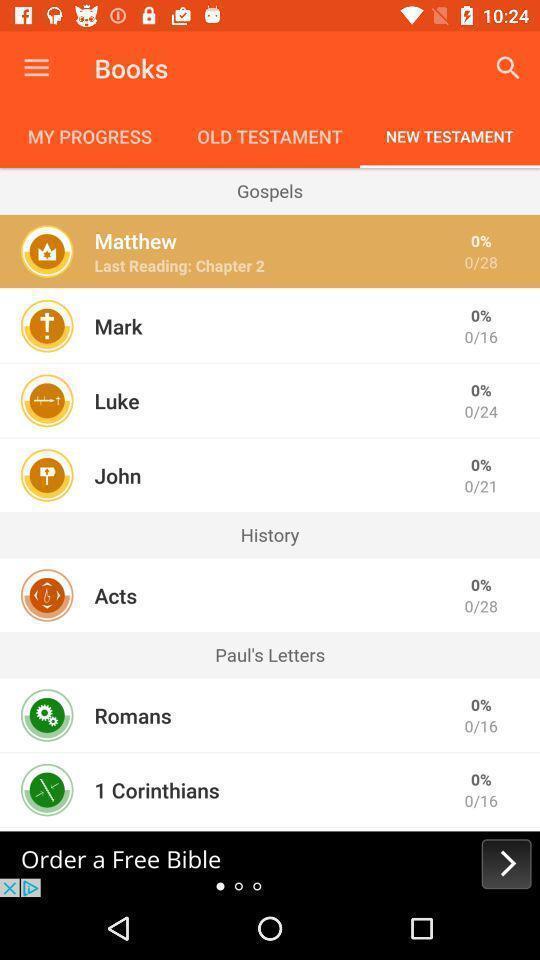Summarize the information in this screenshot. Page displaying list of new testament in app. 